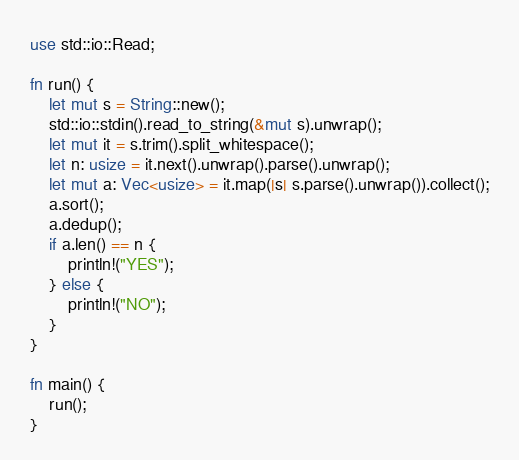<code> <loc_0><loc_0><loc_500><loc_500><_Rust_>use std::io::Read;

fn run() {
    let mut s = String::new();
    std::io::stdin().read_to_string(&mut s).unwrap();
    let mut it = s.trim().split_whitespace();
    let n: usize = it.next().unwrap().parse().unwrap();
    let mut a: Vec<usize> = it.map(|s| s.parse().unwrap()).collect();
    a.sort();
    a.dedup();
    if a.len() == n {
        println!("YES");
    } else {
        println!("NO");
    }
}

fn main() {
    run();
}</code> 